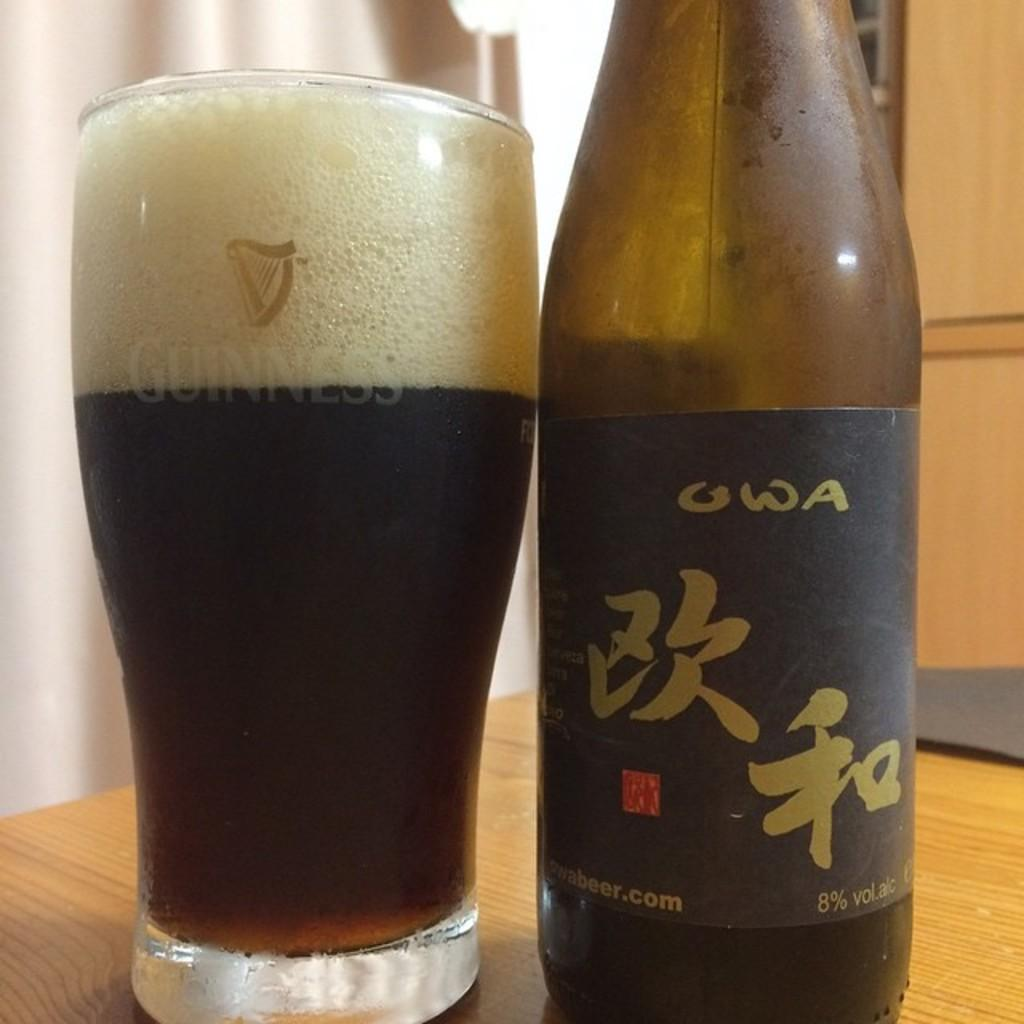<image>
Offer a succinct explanation of the picture presented. A bottle of OWA sits next to a full glass that says Guinness on it. 